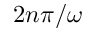<formula> <loc_0><loc_0><loc_500><loc_500>2 n \pi / \omega</formula> 